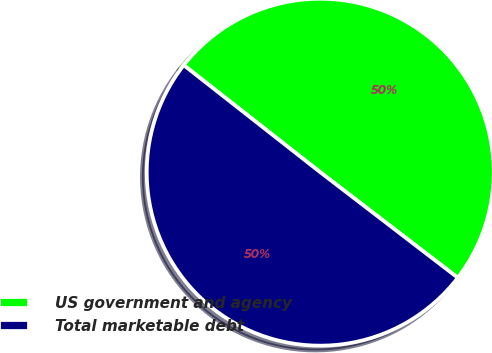Convert chart. <chart><loc_0><loc_0><loc_500><loc_500><pie_chart><fcel>US government and agency<fcel>Total marketable debt<nl><fcel>49.83%<fcel>50.17%<nl></chart> 